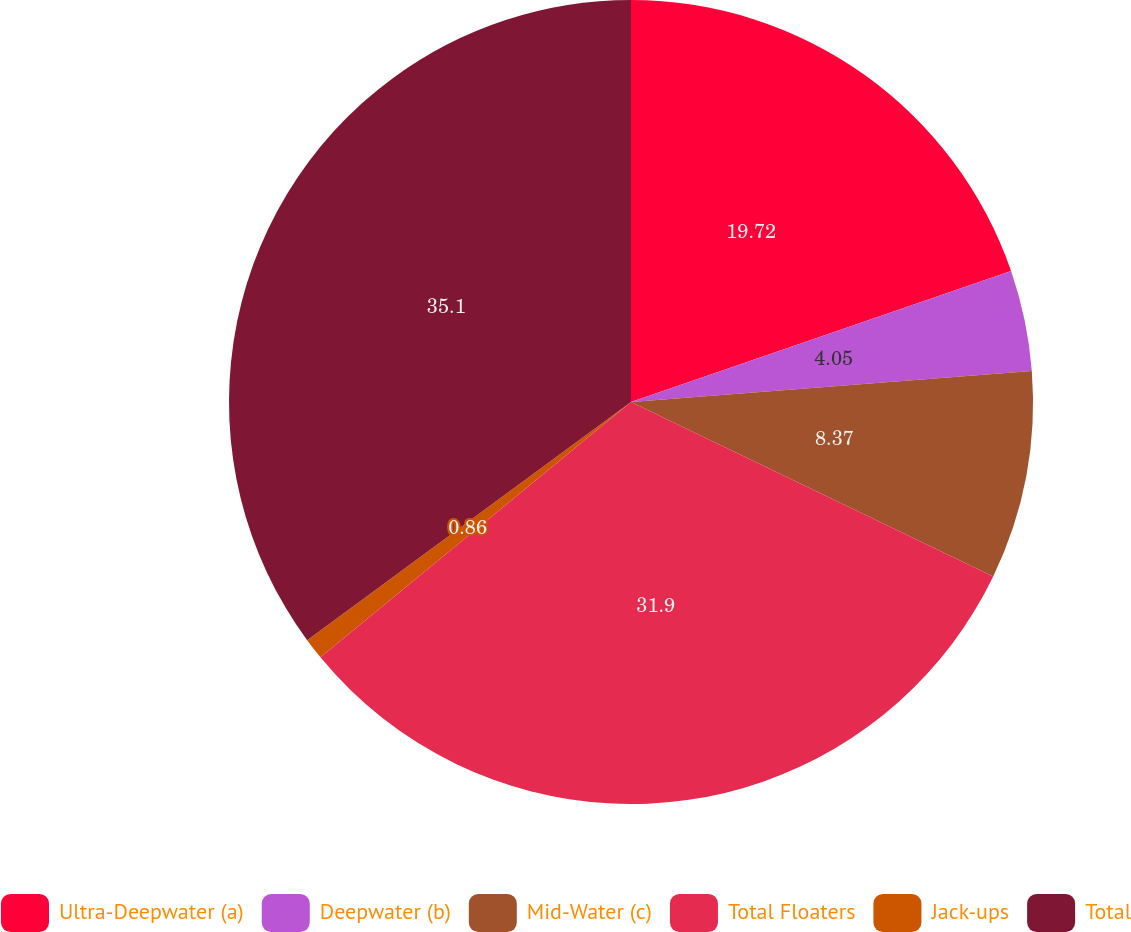Convert chart to OTSL. <chart><loc_0><loc_0><loc_500><loc_500><pie_chart><fcel>Ultra-Deepwater (a)<fcel>Deepwater (b)<fcel>Mid-Water (c)<fcel>Total Floaters<fcel>Jack-ups<fcel>Total<nl><fcel>19.72%<fcel>4.05%<fcel>8.37%<fcel>31.9%<fcel>0.86%<fcel>35.09%<nl></chart> 